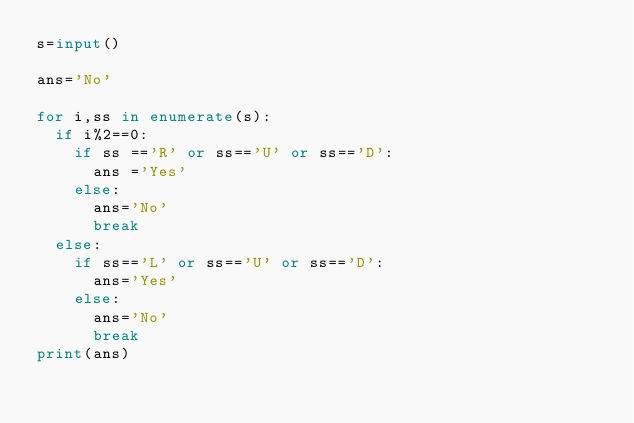<code> <loc_0><loc_0><loc_500><loc_500><_Python_>s=input()

ans='No'

for i,ss in enumerate(s):
  if i%2==0:
    if ss =='R' or ss=='U' or ss=='D':
      ans ='Yes'
    else:
      ans='No'
      break
  else:
    if ss=='L' or ss=='U' or ss=='D':
      ans='Yes'
    else:
      ans='No'
      break
print(ans)</code> 